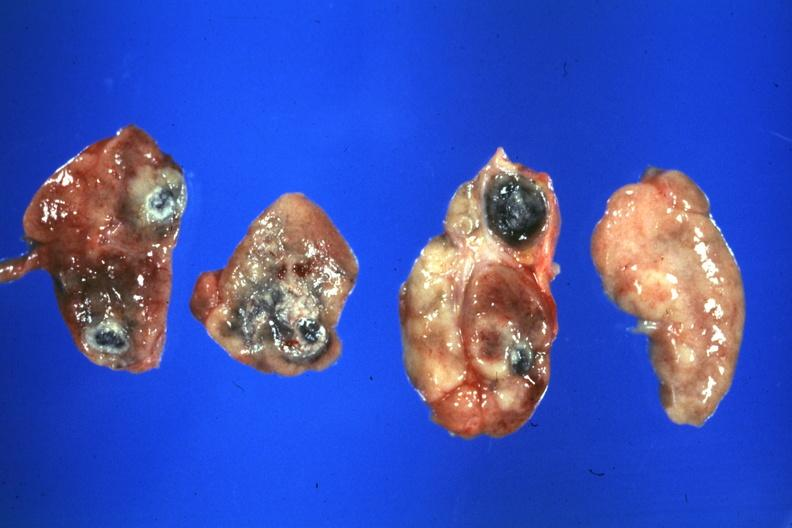what is present?
Answer the question using a single word or phrase. Sarcoidosis 